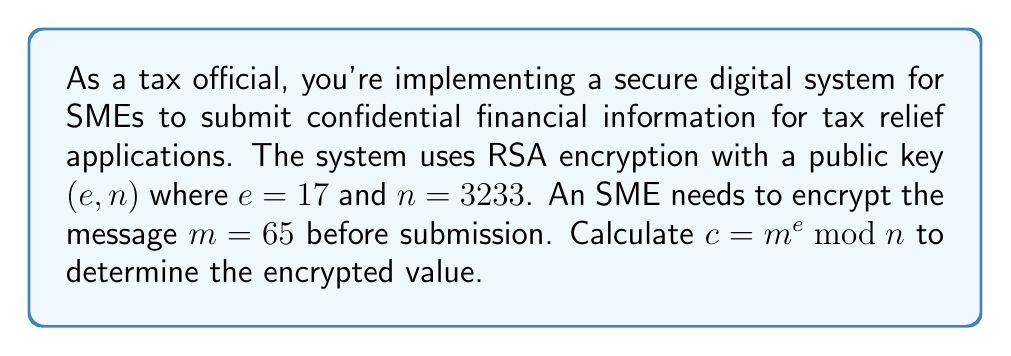Help me with this question. To calculate the modular exponentiation $c = m^e \bmod n$, we'll use the square-and-multiply algorithm, which is efficient for large exponents. Here's the step-by-step process:

1) Convert the exponent $e = 17$ to binary: $17_{10} = 10001_2$

2) Initialize: $result = 1$, $base = m = 65$

3) For each bit in the binary representation of $e$ (from left to right):
   a) Square the result: $result = result^2 \bmod n$
   b) If the bit is 1, multiply by the base: $result = (result \cdot base) \bmod n$

4) Step-by-step calculation:
   - Bit 1: $result = 1^2 \cdot 65 \bmod 3233 = 65$
   - Bit 0: $result = 65^2 \bmod 3233 = 4225 \bmod 3233 = 992$
   - Bit 0: $result = 992^2 \bmod 3233 = 984064 \bmod 3233 = 2893$
   - Bit 0: $result = 2893^2 \bmod 3233 = 8369449 \bmod 3233 = 2998$
   - Bit 1: $result = 2998^2 \cdot 65 \bmod 3233 = (8988004 \cdot 65) \bmod 3233 = 584220260 \bmod 3233 = 2132$

5) Therefore, $c = 65^{17} \bmod 3233 = 2132$
Answer: $2132$ 